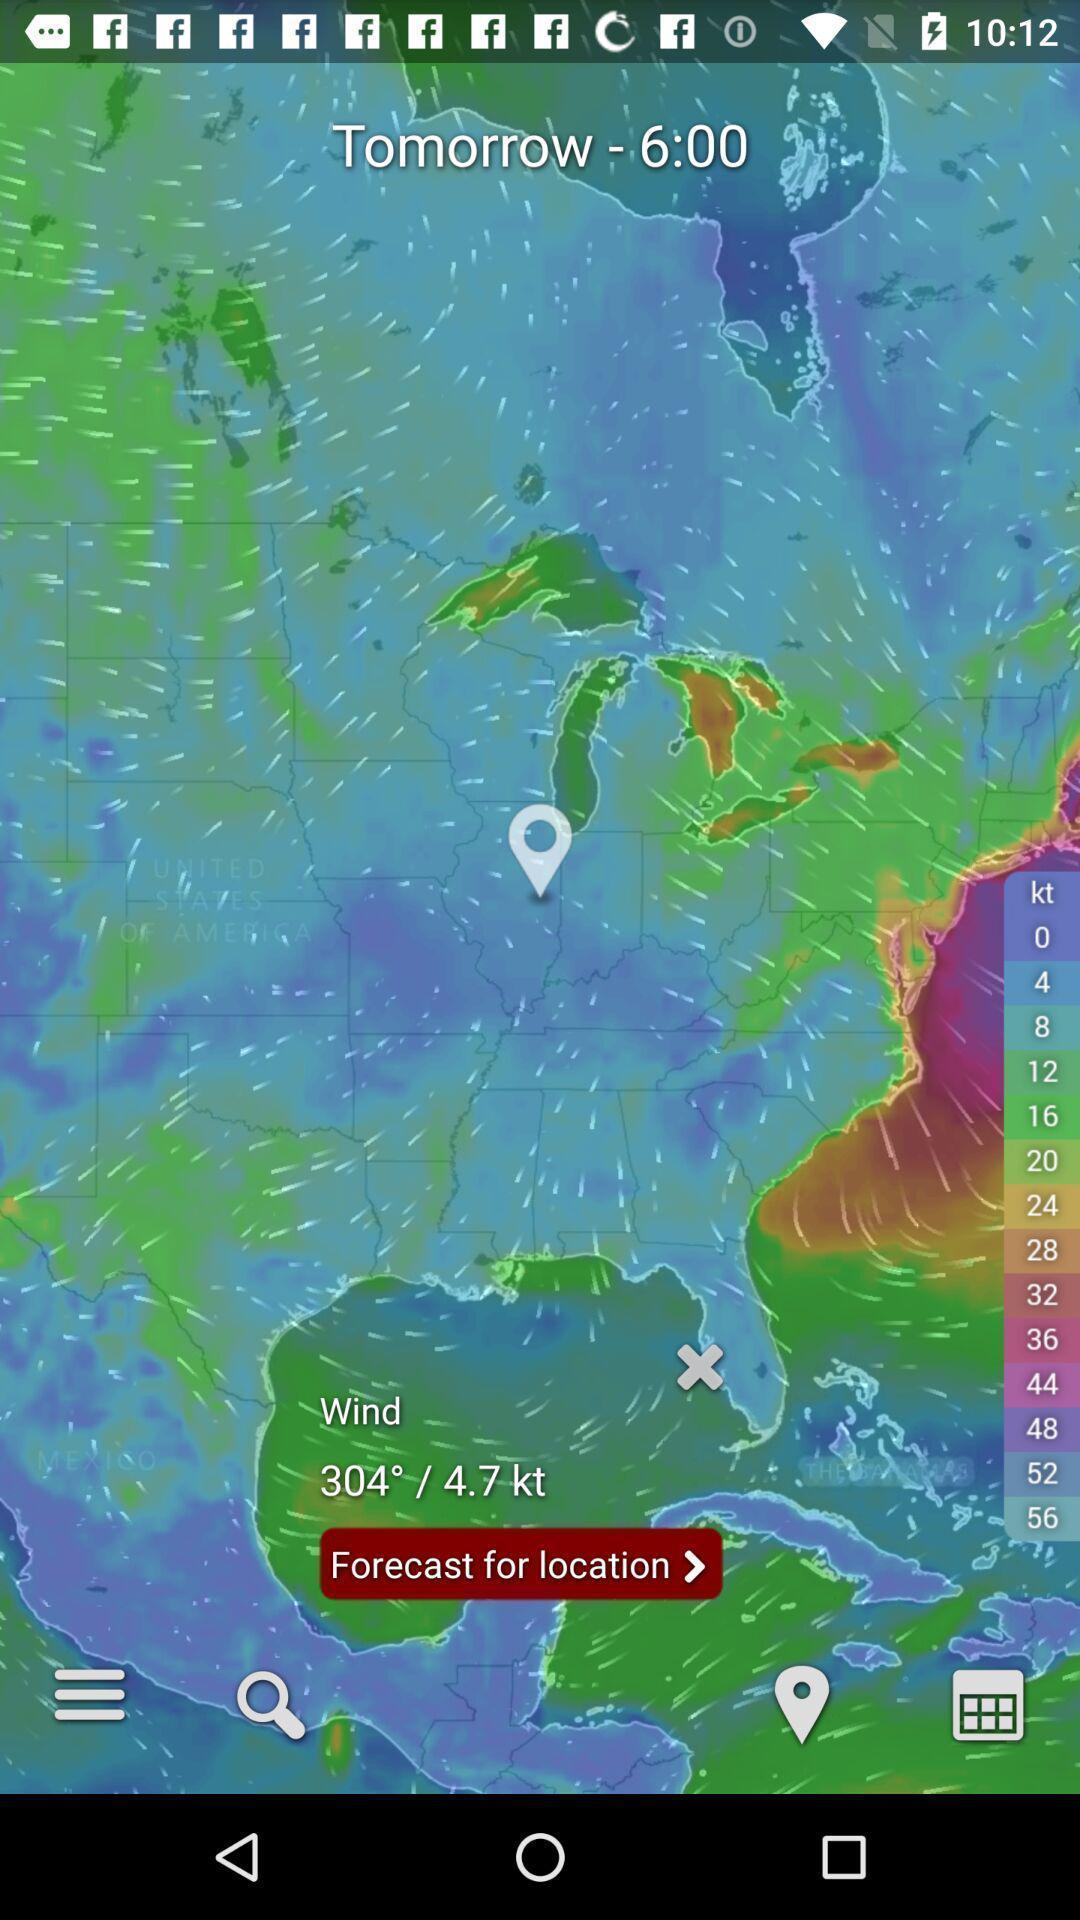Summarize the main components in this picture. Screen shows weather forecast details. 